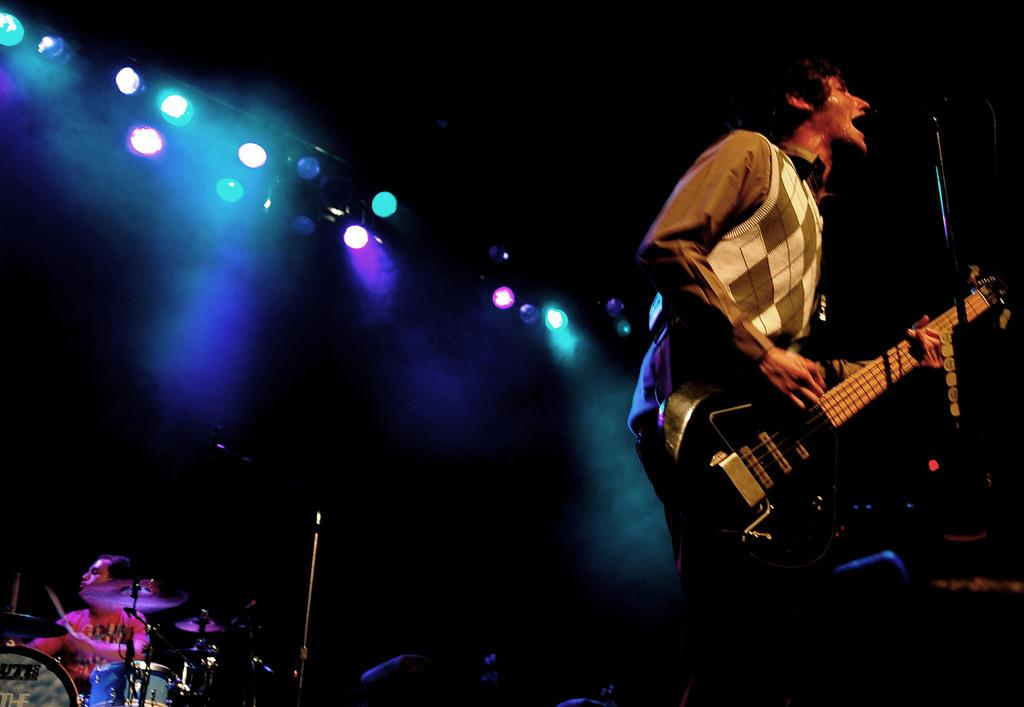What is the man in the image doing? The man is playing a guitar. Can you describe the other person in the image? There is a man sitting in the image, and he is playing drums. What is the lighting like in the image? The background of the image is dark, and there are spotlights visible at the top of the image. What type of soap is the daughter using in the image? There is no daughter or soap present in the image. 